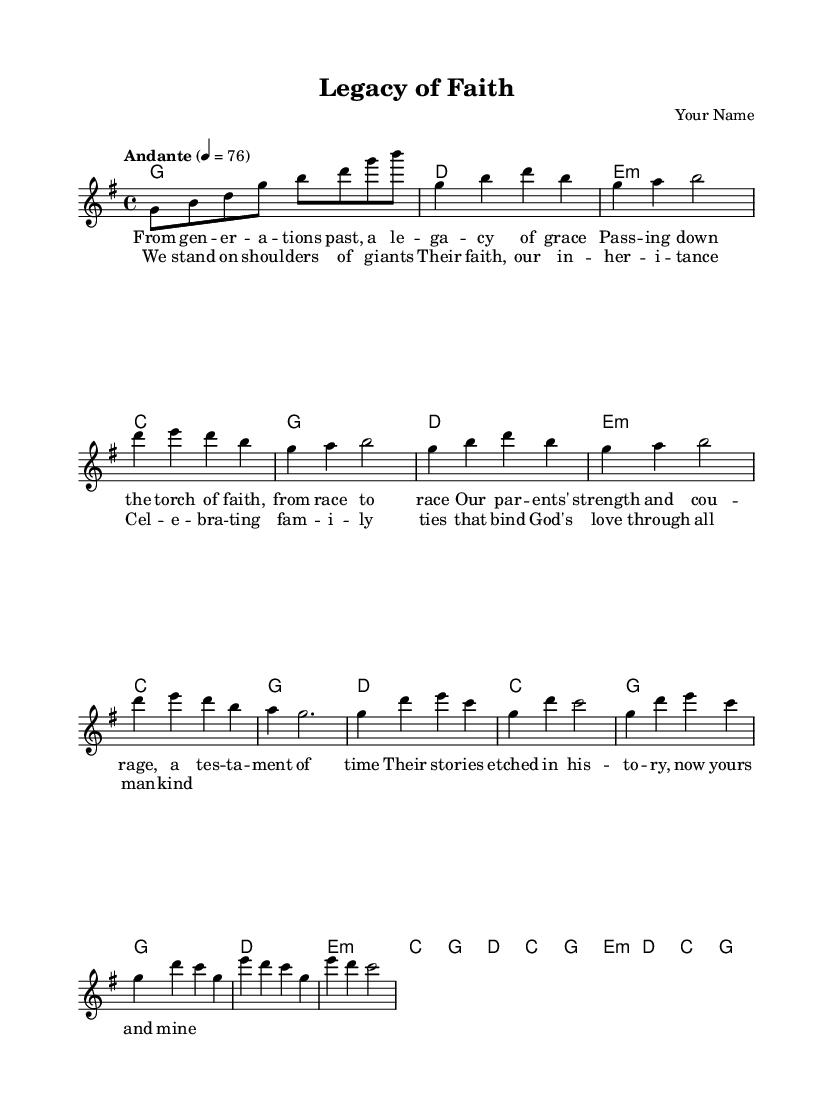What is the key signature of this music? The key signature is G major, which has one sharp (F#). This is found at the beginning of the staff before the notes.
Answer: G major What is the time signature of this music? The time signature is 4/4, indicated at the beginning of the piece. This means there are four beats per measure.
Answer: 4/4 What is the tempo marking for this piece? The tempo marking indicates "Andante," which suggests a moderate pace. This is also indicated in the header section of the sheet music.
Answer: Andante How many verses are there in the song? There is one complete verse represented in the score, as indicated by the structure of the lyrics provided in the sheet music.
Answer: One What are the primary themes of the lyrics? The themes focus on family legacy, faith, and gratitude, as highlighted in the lyrics which discuss generational strength and ties that bind.
Answer: Family, faith, heritage What is the format of the chorus in the music? The chorus has four lines with a repeating structure, focusing on the collective strength inherited from previous generations. This is common in hymns for emphasis on the message.
Answer: Four lines 